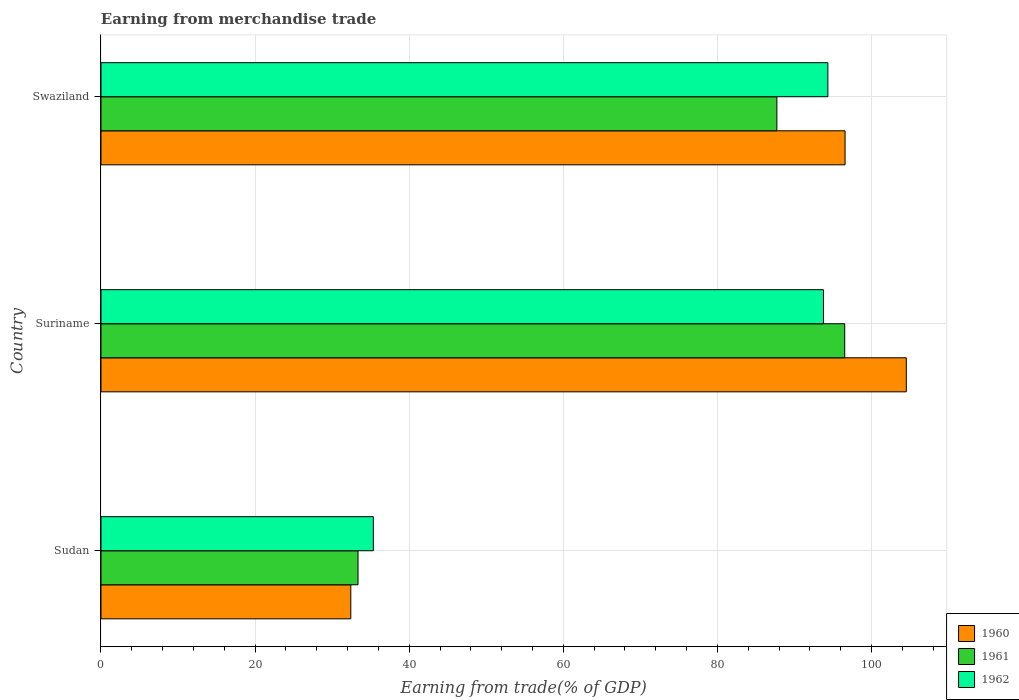Are the number of bars per tick equal to the number of legend labels?
Your answer should be compact. Yes. What is the label of the 1st group of bars from the top?
Offer a terse response. Swaziland. What is the earnings from trade in 1961 in Suriname?
Provide a succinct answer. 96.51. Across all countries, what is the maximum earnings from trade in 1960?
Keep it short and to the point. 104.5. Across all countries, what is the minimum earnings from trade in 1961?
Provide a succinct answer. 33.36. In which country was the earnings from trade in 1961 maximum?
Your response must be concise. Suriname. In which country was the earnings from trade in 1960 minimum?
Give a very brief answer. Sudan. What is the total earnings from trade in 1960 in the graph?
Your answer should be very brief. 233.48. What is the difference between the earnings from trade in 1962 in Suriname and that in Swaziland?
Keep it short and to the point. -0.57. What is the difference between the earnings from trade in 1960 in Sudan and the earnings from trade in 1961 in Suriname?
Make the answer very short. -64.1. What is the average earnings from trade in 1962 per country?
Your answer should be compact. 74.48. What is the difference between the earnings from trade in 1961 and earnings from trade in 1962 in Swaziland?
Ensure brevity in your answer.  -6.62. What is the ratio of the earnings from trade in 1962 in Sudan to that in Swaziland?
Keep it short and to the point. 0.37. Is the difference between the earnings from trade in 1961 in Sudan and Swaziland greater than the difference between the earnings from trade in 1962 in Sudan and Swaziland?
Make the answer very short. Yes. What is the difference between the highest and the second highest earnings from trade in 1962?
Keep it short and to the point. 0.57. What is the difference between the highest and the lowest earnings from trade in 1960?
Provide a short and direct response. 72.09. What does the 2nd bar from the top in Sudan represents?
Keep it short and to the point. 1961. Is it the case that in every country, the sum of the earnings from trade in 1961 and earnings from trade in 1960 is greater than the earnings from trade in 1962?
Offer a terse response. Yes. How many bars are there?
Offer a terse response. 9. Are all the bars in the graph horizontal?
Keep it short and to the point. Yes. What is the difference between two consecutive major ticks on the X-axis?
Your answer should be compact. 20. Does the graph contain any zero values?
Provide a succinct answer. No. What is the title of the graph?
Ensure brevity in your answer.  Earning from merchandise trade. What is the label or title of the X-axis?
Your answer should be very brief. Earning from trade(% of GDP). What is the Earning from trade(% of GDP) of 1960 in Sudan?
Your answer should be very brief. 32.42. What is the Earning from trade(% of GDP) of 1961 in Sudan?
Provide a succinct answer. 33.36. What is the Earning from trade(% of GDP) of 1962 in Sudan?
Give a very brief answer. 35.34. What is the Earning from trade(% of GDP) in 1960 in Suriname?
Provide a short and direct response. 104.5. What is the Earning from trade(% of GDP) in 1961 in Suriname?
Your response must be concise. 96.51. What is the Earning from trade(% of GDP) of 1962 in Suriname?
Ensure brevity in your answer.  93.76. What is the Earning from trade(% of GDP) in 1960 in Swaziland?
Your answer should be compact. 96.56. What is the Earning from trade(% of GDP) of 1961 in Swaziland?
Make the answer very short. 87.71. What is the Earning from trade(% of GDP) of 1962 in Swaziland?
Make the answer very short. 94.33. Across all countries, what is the maximum Earning from trade(% of GDP) of 1960?
Your answer should be very brief. 104.5. Across all countries, what is the maximum Earning from trade(% of GDP) in 1961?
Offer a very short reply. 96.51. Across all countries, what is the maximum Earning from trade(% of GDP) of 1962?
Your answer should be very brief. 94.33. Across all countries, what is the minimum Earning from trade(% of GDP) in 1960?
Your response must be concise. 32.42. Across all countries, what is the minimum Earning from trade(% of GDP) in 1961?
Your answer should be very brief. 33.36. Across all countries, what is the minimum Earning from trade(% of GDP) in 1962?
Provide a succinct answer. 35.34. What is the total Earning from trade(% of GDP) of 1960 in the graph?
Your answer should be compact. 233.48. What is the total Earning from trade(% of GDP) in 1961 in the graph?
Make the answer very short. 217.58. What is the total Earning from trade(% of GDP) of 1962 in the graph?
Provide a succinct answer. 223.43. What is the difference between the Earning from trade(% of GDP) of 1960 in Sudan and that in Suriname?
Provide a short and direct response. -72.09. What is the difference between the Earning from trade(% of GDP) in 1961 in Sudan and that in Suriname?
Provide a short and direct response. -63.16. What is the difference between the Earning from trade(% of GDP) of 1962 in Sudan and that in Suriname?
Make the answer very short. -58.41. What is the difference between the Earning from trade(% of GDP) in 1960 in Sudan and that in Swaziland?
Give a very brief answer. -64.14. What is the difference between the Earning from trade(% of GDP) of 1961 in Sudan and that in Swaziland?
Your response must be concise. -54.35. What is the difference between the Earning from trade(% of GDP) of 1962 in Sudan and that in Swaziland?
Make the answer very short. -58.98. What is the difference between the Earning from trade(% of GDP) of 1960 in Suriname and that in Swaziland?
Your answer should be compact. 7.94. What is the difference between the Earning from trade(% of GDP) of 1961 in Suriname and that in Swaziland?
Offer a very short reply. 8.8. What is the difference between the Earning from trade(% of GDP) of 1962 in Suriname and that in Swaziland?
Provide a succinct answer. -0.57. What is the difference between the Earning from trade(% of GDP) of 1960 in Sudan and the Earning from trade(% of GDP) of 1961 in Suriname?
Make the answer very short. -64.1. What is the difference between the Earning from trade(% of GDP) of 1960 in Sudan and the Earning from trade(% of GDP) of 1962 in Suriname?
Ensure brevity in your answer.  -61.34. What is the difference between the Earning from trade(% of GDP) in 1961 in Sudan and the Earning from trade(% of GDP) in 1962 in Suriname?
Ensure brevity in your answer.  -60.4. What is the difference between the Earning from trade(% of GDP) in 1960 in Sudan and the Earning from trade(% of GDP) in 1961 in Swaziland?
Ensure brevity in your answer.  -55.29. What is the difference between the Earning from trade(% of GDP) in 1960 in Sudan and the Earning from trade(% of GDP) in 1962 in Swaziland?
Keep it short and to the point. -61.91. What is the difference between the Earning from trade(% of GDP) in 1961 in Sudan and the Earning from trade(% of GDP) in 1962 in Swaziland?
Ensure brevity in your answer.  -60.97. What is the difference between the Earning from trade(% of GDP) of 1960 in Suriname and the Earning from trade(% of GDP) of 1961 in Swaziland?
Your answer should be compact. 16.79. What is the difference between the Earning from trade(% of GDP) in 1960 in Suriname and the Earning from trade(% of GDP) in 1962 in Swaziland?
Give a very brief answer. 10.18. What is the difference between the Earning from trade(% of GDP) in 1961 in Suriname and the Earning from trade(% of GDP) in 1962 in Swaziland?
Your answer should be very brief. 2.19. What is the average Earning from trade(% of GDP) of 1960 per country?
Keep it short and to the point. 77.83. What is the average Earning from trade(% of GDP) of 1961 per country?
Keep it short and to the point. 72.53. What is the average Earning from trade(% of GDP) of 1962 per country?
Provide a succinct answer. 74.48. What is the difference between the Earning from trade(% of GDP) of 1960 and Earning from trade(% of GDP) of 1961 in Sudan?
Ensure brevity in your answer.  -0.94. What is the difference between the Earning from trade(% of GDP) of 1960 and Earning from trade(% of GDP) of 1962 in Sudan?
Offer a terse response. -2.92. What is the difference between the Earning from trade(% of GDP) of 1961 and Earning from trade(% of GDP) of 1962 in Sudan?
Make the answer very short. -1.99. What is the difference between the Earning from trade(% of GDP) in 1960 and Earning from trade(% of GDP) in 1961 in Suriname?
Your answer should be very brief. 7.99. What is the difference between the Earning from trade(% of GDP) in 1960 and Earning from trade(% of GDP) in 1962 in Suriname?
Ensure brevity in your answer.  10.75. What is the difference between the Earning from trade(% of GDP) in 1961 and Earning from trade(% of GDP) in 1962 in Suriname?
Keep it short and to the point. 2.76. What is the difference between the Earning from trade(% of GDP) in 1960 and Earning from trade(% of GDP) in 1961 in Swaziland?
Make the answer very short. 8.85. What is the difference between the Earning from trade(% of GDP) of 1960 and Earning from trade(% of GDP) of 1962 in Swaziland?
Provide a short and direct response. 2.23. What is the difference between the Earning from trade(% of GDP) in 1961 and Earning from trade(% of GDP) in 1962 in Swaziland?
Provide a succinct answer. -6.62. What is the ratio of the Earning from trade(% of GDP) in 1960 in Sudan to that in Suriname?
Provide a succinct answer. 0.31. What is the ratio of the Earning from trade(% of GDP) in 1961 in Sudan to that in Suriname?
Make the answer very short. 0.35. What is the ratio of the Earning from trade(% of GDP) of 1962 in Sudan to that in Suriname?
Offer a terse response. 0.38. What is the ratio of the Earning from trade(% of GDP) of 1960 in Sudan to that in Swaziland?
Your answer should be compact. 0.34. What is the ratio of the Earning from trade(% of GDP) in 1961 in Sudan to that in Swaziland?
Offer a terse response. 0.38. What is the ratio of the Earning from trade(% of GDP) of 1962 in Sudan to that in Swaziland?
Your answer should be very brief. 0.37. What is the ratio of the Earning from trade(% of GDP) of 1960 in Suriname to that in Swaziland?
Make the answer very short. 1.08. What is the ratio of the Earning from trade(% of GDP) in 1961 in Suriname to that in Swaziland?
Keep it short and to the point. 1.1. What is the ratio of the Earning from trade(% of GDP) in 1962 in Suriname to that in Swaziland?
Provide a succinct answer. 0.99. What is the difference between the highest and the second highest Earning from trade(% of GDP) of 1960?
Provide a succinct answer. 7.94. What is the difference between the highest and the second highest Earning from trade(% of GDP) in 1961?
Keep it short and to the point. 8.8. What is the difference between the highest and the second highest Earning from trade(% of GDP) in 1962?
Offer a terse response. 0.57. What is the difference between the highest and the lowest Earning from trade(% of GDP) in 1960?
Offer a terse response. 72.09. What is the difference between the highest and the lowest Earning from trade(% of GDP) in 1961?
Offer a terse response. 63.16. What is the difference between the highest and the lowest Earning from trade(% of GDP) of 1962?
Give a very brief answer. 58.98. 